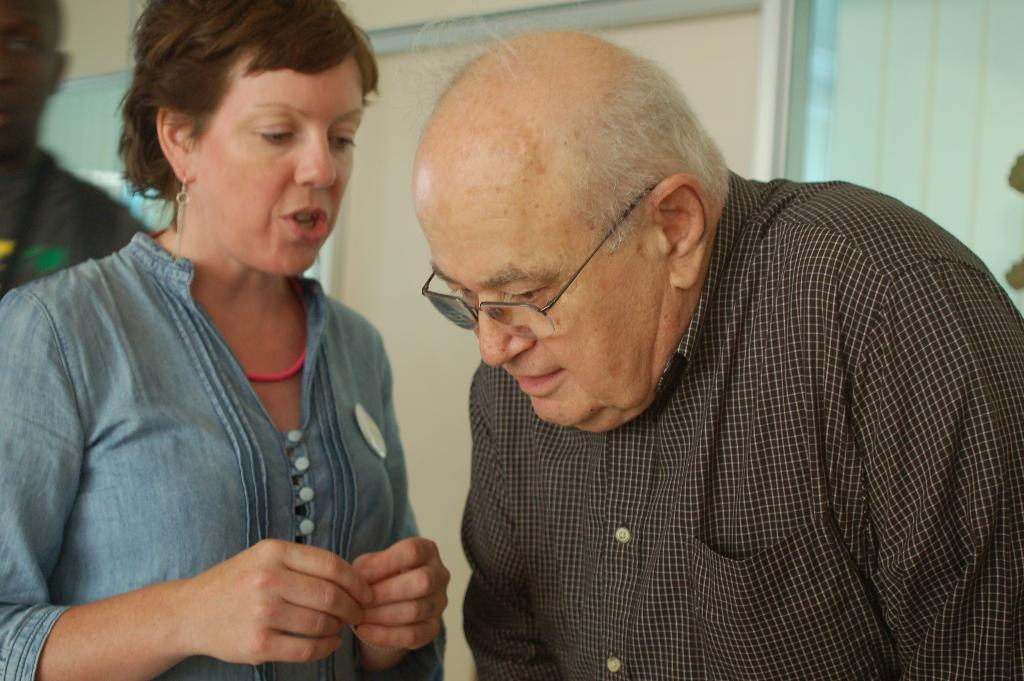What is the man in the image wearing? The man in the image is wearing spectacles. What is the woman in the image doing? The woman in the image is talking to the man. Can you describe the background of the image? There is a wall and a curtain in the background of the image. Are there any other people visible in the image? Yes, there is another man in the background of the image. What type of goose is sitting on the man's head in the image? There is no goose present in the image; the man is wearing spectacles, and the woman is talking to him. What color is the sock on the woman's foot in the image? There is no information about socks or the woman's feet in the image. 